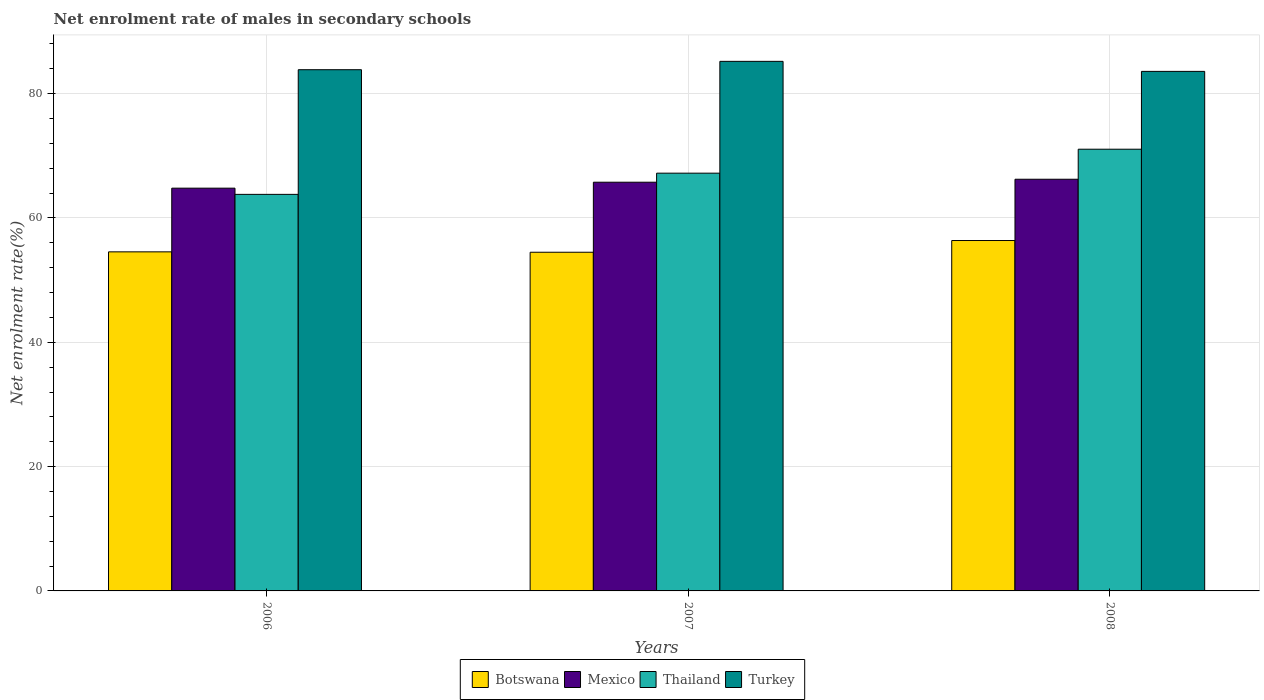How many groups of bars are there?
Make the answer very short. 3. In how many cases, is the number of bars for a given year not equal to the number of legend labels?
Ensure brevity in your answer.  0. What is the net enrolment rate of males in secondary schools in Mexico in 2007?
Ensure brevity in your answer.  65.75. Across all years, what is the maximum net enrolment rate of males in secondary schools in Botswana?
Your answer should be very brief. 56.37. Across all years, what is the minimum net enrolment rate of males in secondary schools in Turkey?
Ensure brevity in your answer.  83.58. What is the total net enrolment rate of males in secondary schools in Mexico in the graph?
Provide a succinct answer. 196.78. What is the difference between the net enrolment rate of males in secondary schools in Turkey in 2006 and that in 2008?
Offer a terse response. 0.27. What is the difference between the net enrolment rate of males in secondary schools in Turkey in 2008 and the net enrolment rate of males in secondary schools in Thailand in 2006?
Give a very brief answer. 19.78. What is the average net enrolment rate of males in secondary schools in Botswana per year?
Your answer should be compact. 55.14. In the year 2006, what is the difference between the net enrolment rate of males in secondary schools in Mexico and net enrolment rate of males in secondary schools in Botswana?
Provide a succinct answer. 10.24. In how many years, is the net enrolment rate of males in secondary schools in Mexico greater than 84 %?
Offer a terse response. 0. What is the ratio of the net enrolment rate of males in secondary schools in Thailand in 2007 to that in 2008?
Provide a succinct answer. 0.95. Is the net enrolment rate of males in secondary schools in Thailand in 2007 less than that in 2008?
Give a very brief answer. Yes. Is the difference between the net enrolment rate of males in secondary schools in Mexico in 2007 and 2008 greater than the difference between the net enrolment rate of males in secondary schools in Botswana in 2007 and 2008?
Keep it short and to the point. Yes. What is the difference between the highest and the second highest net enrolment rate of males in secondary schools in Turkey?
Offer a terse response. 1.34. What is the difference between the highest and the lowest net enrolment rate of males in secondary schools in Botswana?
Provide a short and direct response. 1.88. Is the sum of the net enrolment rate of males in secondary schools in Turkey in 2006 and 2008 greater than the maximum net enrolment rate of males in secondary schools in Thailand across all years?
Offer a very short reply. Yes. What does the 3rd bar from the left in 2008 represents?
Make the answer very short. Thailand. How many bars are there?
Your answer should be compact. 12. Are all the bars in the graph horizontal?
Give a very brief answer. No. What is the difference between two consecutive major ticks on the Y-axis?
Provide a short and direct response. 20. Are the values on the major ticks of Y-axis written in scientific E-notation?
Offer a very short reply. No. Does the graph contain any zero values?
Ensure brevity in your answer.  No. Does the graph contain grids?
Keep it short and to the point. Yes. How are the legend labels stacked?
Your response must be concise. Horizontal. What is the title of the graph?
Offer a terse response. Net enrolment rate of males in secondary schools. Does "Cambodia" appear as one of the legend labels in the graph?
Your answer should be very brief. No. What is the label or title of the Y-axis?
Offer a terse response. Net enrolment rate(%). What is the Net enrolment rate(%) of Botswana in 2006?
Your response must be concise. 54.55. What is the Net enrolment rate(%) of Mexico in 2006?
Make the answer very short. 64.79. What is the Net enrolment rate(%) in Thailand in 2006?
Your answer should be very brief. 63.8. What is the Net enrolment rate(%) of Turkey in 2006?
Provide a short and direct response. 83.85. What is the Net enrolment rate(%) in Botswana in 2007?
Provide a succinct answer. 54.49. What is the Net enrolment rate(%) of Mexico in 2007?
Your answer should be very brief. 65.75. What is the Net enrolment rate(%) of Thailand in 2007?
Your response must be concise. 67.21. What is the Net enrolment rate(%) of Turkey in 2007?
Your response must be concise. 85.2. What is the Net enrolment rate(%) in Botswana in 2008?
Ensure brevity in your answer.  56.37. What is the Net enrolment rate(%) of Mexico in 2008?
Provide a short and direct response. 66.23. What is the Net enrolment rate(%) in Thailand in 2008?
Your answer should be very brief. 71.06. What is the Net enrolment rate(%) of Turkey in 2008?
Ensure brevity in your answer.  83.58. Across all years, what is the maximum Net enrolment rate(%) of Botswana?
Offer a very short reply. 56.37. Across all years, what is the maximum Net enrolment rate(%) of Mexico?
Provide a succinct answer. 66.23. Across all years, what is the maximum Net enrolment rate(%) of Thailand?
Provide a succinct answer. 71.06. Across all years, what is the maximum Net enrolment rate(%) in Turkey?
Your answer should be compact. 85.2. Across all years, what is the minimum Net enrolment rate(%) of Botswana?
Offer a terse response. 54.49. Across all years, what is the minimum Net enrolment rate(%) in Mexico?
Offer a terse response. 64.79. Across all years, what is the minimum Net enrolment rate(%) in Thailand?
Provide a succinct answer. 63.8. Across all years, what is the minimum Net enrolment rate(%) of Turkey?
Provide a succinct answer. 83.58. What is the total Net enrolment rate(%) of Botswana in the graph?
Your answer should be very brief. 165.41. What is the total Net enrolment rate(%) of Mexico in the graph?
Offer a terse response. 196.78. What is the total Net enrolment rate(%) in Thailand in the graph?
Keep it short and to the point. 202.07. What is the total Net enrolment rate(%) in Turkey in the graph?
Your response must be concise. 252.63. What is the difference between the Net enrolment rate(%) in Botswana in 2006 and that in 2007?
Ensure brevity in your answer.  0.06. What is the difference between the Net enrolment rate(%) in Mexico in 2006 and that in 2007?
Offer a terse response. -0.96. What is the difference between the Net enrolment rate(%) in Thailand in 2006 and that in 2007?
Provide a short and direct response. -3.41. What is the difference between the Net enrolment rate(%) in Turkey in 2006 and that in 2007?
Your answer should be very brief. -1.34. What is the difference between the Net enrolment rate(%) in Botswana in 2006 and that in 2008?
Offer a very short reply. -1.82. What is the difference between the Net enrolment rate(%) of Mexico in 2006 and that in 2008?
Provide a succinct answer. -1.44. What is the difference between the Net enrolment rate(%) in Thailand in 2006 and that in 2008?
Ensure brevity in your answer.  -7.26. What is the difference between the Net enrolment rate(%) in Turkey in 2006 and that in 2008?
Provide a succinct answer. 0.27. What is the difference between the Net enrolment rate(%) in Botswana in 2007 and that in 2008?
Provide a succinct answer. -1.88. What is the difference between the Net enrolment rate(%) in Mexico in 2007 and that in 2008?
Your answer should be very brief. -0.48. What is the difference between the Net enrolment rate(%) of Thailand in 2007 and that in 2008?
Your response must be concise. -3.85. What is the difference between the Net enrolment rate(%) of Turkey in 2007 and that in 2008?
Provide a succinct answer. 1.61. What is the difference between the Net enrolment rate(%) in Botswana in 2006 and the Net enrolment rate(%) in Mexico in 2007?
Give a very brief answer. -11.2. What is the difference between the Net enrolment rate(%) of Botswana in 2006 and the Net enrolment rate(%) of Thailand in 2007?
Provide a succinct answer. -12.66. What is the difference between the Net enrolment rate(%) of Botswana in 2006 and the Net enrolment rate(%) of Turkey in 2007?
Offer a very short reply. -30.65. What is the difference between the Net enrolment rate(%) of Mexico in 2006 and the Net enrolment rate(%) of Thailand in 2007?
Your answer should be compact. -2.41. What is the difference between the Net enrolment rate(%) in Mexico in 2006 and the Net enrolment rate(%) in Turkey in 2007?
Make the answer very short. -20.4. What is the difference between the Net enrolment rate(%) of Thailand in 2006 and the Net enrolment rate(%) of Turkey in 2007?
Offer a very short reply. -21.4. What is the difference between the Net enrolment rate(%) in Botswana in 2006 and the Net enrolment rate(%) in Mexico in 2008?
Make the answer very short. -11.68. What is the difference between the Net enrolment rate(%) of Botswana in 2006 and the Net enrolment rate(%) of Thailand in 2008?
Ensure brevity in your answer.  -16.51. What is the difference between the Net enrolment rate(%) in Botswana in 2006 and the Net enrolment rate(%) in Turkey in 2008?
Offer a terse response. -29.03. What is the difference between the Net enrolment rate(%) in Mexico in 2006 and the Net enrolment rate(%) in Thailand in 2008?
Provide a short and direct response. -6.27. What is the difference between the Net enrolment rate(%) of Mexico in 2006 and the Net enrolment rate(%) of Turkey in 2008?
Make the answer very short. -18.79. What is the difference between the Net enrolment rate(%) of Thailand in 2006 and the Net enrolment rate(%) of Turkey in 2008?
Ensure brevity in your answer.  -19.78. What is the difference between the Net enrolment rate(%) in Botswana in 2007 and the Net enrolment rate(%) in Mexico in 2008?
Offer a very short reply. -11.74. What is the difference between the Net enrolment rate(%) in Botswana in 2007 and the Net enrolment rate(%) in Thailand in 2008?
Your answer should be compact. -16.58. What is the difference between the Net enrolment rate(%) of Botswana in 2007 and the Net enrolment rate(%) of Turkey in 2008?
Give a very brief answer. -29.1. What is the difference between the Net enrolment rate(%) in Mexico in 2007 and the Net enrolment rate(%) in Thailand in 2008?
Your answer should be compact. -5.31. What is the difference between the Net enrolment rate(%) of Mexico in 2007 and the Net enrolment rate(%) of Turkey in 2008?
Offer a very short reply. -17.83. What is the difference between the Net enrolment rate(%) in Thailand in 2007 and the Net enrolment rate(%) in Turkey in 2008?
Keep it short and to the point. -16.37. What is the average Net enrolment rate(%) in Botswana per year?
Your response must be concise. 55.14. What is the average Net enrolment rate(%) in Mexico per year?
Your response must be concise. 65.59. What is the average Net enrolment rate(%) in Thailand per year?
Offer a terse response. 67.36. What is the average Net enrolment rate(%) of Turkey per year?
Give a very brief answer. 84.21. In the year 2006, what is the difference between the Net enrolment rate(%) in Botswana and Net enrolment rate(%) in Mexico?
Your response must be concise. -10.24. In the year 2006, what is the difference between the Net enrolment rate(%) in Botswana and Net enrolment rate(%) in Thailand?
Your response must be concise. -9.25. In the year 2006, what is the difference between the Net enrolment rate(%) of Botswana and Net enrolment rate(%) of Turkey?
Your response must be concise. -29.3. In the year 2006, what is the difference between the Net enrolment rate(%) in Mexico and Net enrolment rate(%) in Turkey?
Your answer should be very brief. -19.06. In the year 2006, what is the difference between the Net enrolment rate(%) of Thailand and Net enrolment rate(%) of Turkey?
Offer a terse response. -20.05. In the year 2007, what is the difference between the Net enrolment rate(%) in Botswana and Net enrolment rate(%) in Mexico?
Your answer should be very brief. -11.26. In the year 2007, what is the difference between the Net enrolment rate(%) in Botswana and Net enrolment rate(%) in Thailand?
Keep it short and to the point. -12.72. In the year 2007, what is the difference between the Net enrolment rate(%) of Botswana and Net enrolment rate(%) of Turkey?
Provide a short and direct response. -30.71. In the year 2007, what is the difference between the Net enrolment rate(%) in Mexico and Net enrolment rate(%) in Thailand?
Your answer should be very brief. -1.46. In the year 2007, what is the difference between the Net enrolment rate(%) in Mexico and Net enrolment rate(%) in Turkey?
Keep it short and to the point. -19.44. In the year 2007, what is the difference between the Net enrolment rate(%) in Thailand and Net enrolment rate(%) in Turkey?
Offer a terse response. -17.99. In the year 2008, what is the difference between the Net enrolment rate(%) of Botswana and Net enrolment rate(%) of Mexico?
Ensure brevity in your answer.  -9.86. In the year 2008, what is the difference between the Net enrolment rate(%) of Botswana and Net enrolment rate(%) of Thailand?
Give a very brief answer. -14.69. In the year 2008, what is the difference between the Net enrolment rate(%) in Botswana and Net enrolment rate(%) in Turkey?
Provide a short and direct response. -27.21. In the year 2008, what is the difference between the Net enrolment rate(%) in Mexico and Net enrolment rate(%) in Thailand?
Keep it short and to the point. -4.83. In the year 2008, what is the difference between the Net enrolment rate(%) in Mexico and Net enrolment rate(%) in Turkey?
Keep it short and to the point. -17.35. In the year 2008, what is the difference between the Net enrolment rate(%) in Thailand and Net enrolment rate(%) in Turkey?
Offer a very short reply. -12.52. What is the ratio of the Net enrolment rate(%) of Botswana in 2006 to that in 2007?
Ensure brevity in your answer.  1. What is the ratio of the Net enrolment rate(%) of Mexico in 2006 to that in 2007?
Provide a short and direct response. 0.99. What is the ratio of the Net enrolment rate(%) of Thailand in 2006 to that in 2007?
Ensure brevity in your answer.  0.95. What is the ratio of the Net enrolment rate(%) of Turkey in 2006 to that in 2007?
Give a very brief answer. 0.98. What is the ratio of the Net enrolment rate(%) of Botswana in 2006 to that in 2008?
Give a very brief answer. 0.97. What is the ratio of the Net enrolment rate(%) in Mexico in 2006 to that in 2008?
Offer a very short reply. 0.98. What is the ratio of the Net enrolment rate(%) of Thailand in 2006 to that in 2008?
Offer a terse response. 0.9. What is the ratio of the Net enrolment rate(%) in Botswana in 2007 to that in 2008?
Offer a terse response. 0.97. What is the ratio of the Net enrolment rate(%) of Thailand in 2007 to that in 2008?
Your answer should be compact. 0.95. What is the ratio of the Net enrolment rate(%) of Turkey in 2007 to that in 2008?
Your answer should be very brief. 1.02. What is the difference between the highest and the second highest Net enrolment rate(%) of Botswana?
Your response must be concise. 1.82. What is the difference between the highest and the second highest Net enrolment rate(%) of Mexico?
Give a very brief answer. 0.48. What is the difference between the highest and the second highest Net enrolment rate(%) in Thailand?
Your response must be concise. 3.85. What is the difference between the highest and the second highest Net enrolment rate(%) of Turkey?
Offer a terse response. 1.34. What is the difference between the highest and the lowest Net enrolment rate(%) in Botswana?
Make the answer very short. 1.88. What is the difference between the highest and the lowest Net enrolment rate(%) in Mexico?
Your answer should be very brief. 1.44. What is the difference between the highest and the lowest Net enrolment rate(%) in Thailand?
Provide a succinct answer. 7.26. What is the difference between the highest and the lowest Net enrolment rate(%) in Turkey?
Make the answer very short. 1.61. 